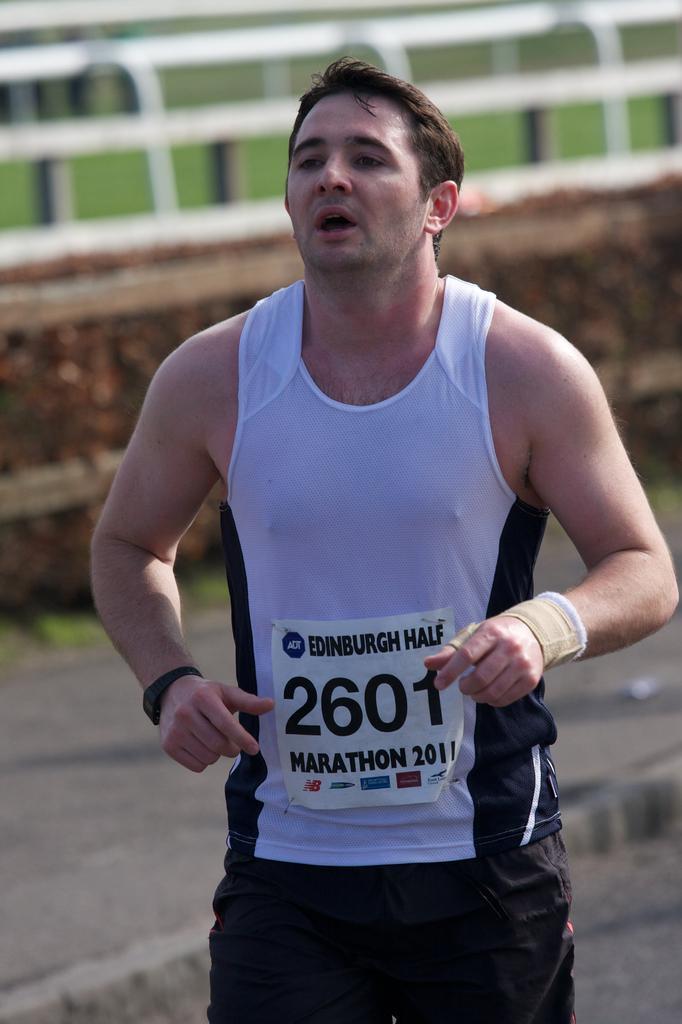How would you summarize this image in a sentence or two? This image is taken outdoors. In the middle of the image a man is running on the road. In the background there is a wall with a railing and there is a ground with grass on it. 